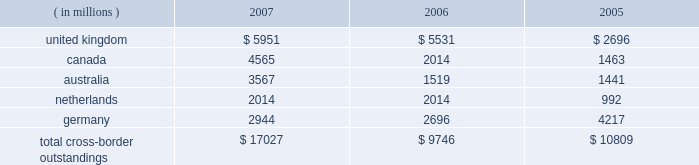Cross-border outstandings to countries in which we do business which amounted to at least 1% ( 1 % ) of our consolidated total assets were as follows as of december 31 : 2007 2006 2005 ( in millions ) .
The total cross-border outstandings presented in the table represented 12% ( 12 % ) , 9% ( 9 % ) and 11% ( 11 % ) of our consolidated total assets as of december 31 , 2007 , 2006 and 2005 , respectively .
There were no cross- border outstandings to countries which totaled between .75% ( .75 % ) and 1% ( 1 % ) of our consolidated total assets as of december 31 , 2007 .
Aggregate cross-border outstandings to countries which totaled between .75% ( .75 % ) and 1% ( 1 % ) of our consolidated total assets at december 31 , 2006 , amounted to $ 1.05 billion ( canada ) and at december 31 , 2005 , amounted to $ 1.86 billion ( belgium and japan ) .
Capital regulatory and economic capital management both use key metrics evaluated by management to ensure that our actual level of capital is commensurate with our risk profile , is in compliance with all regulatory requirements , and is sufficient to provide us with the financial flexibility to undertake future strategic business initiatives .
Regulatory capital our objective with respect to regulatory capital management is to maintain a strong capital base in order to provide financial flexibility for our business needs , including funding corporate growth and supporting customers 2019 cash management needs , and to provide protection against loss to depositors and creditors .
We strive to maintain an optimal level of capital , commensurate with our risk profile , on which an attractive return to shareholders will be realized over both the short and long term , while protecting our obligations to depositors and creditors and satisfying regulatory requirements .
Our capital management process focuses on our risk exposures , our capital position relative to our peers , regulatory capital requirements and the evaluations of the major independent credit rating agencies that assign ratings to our public debt .
The capital committee , working in conjunction with the asset and liability committee , referred to as 2018 2018alco , 2019 2019 oversees the management of regulatory capital , and is responsible for ensuring capital adequacy with respect to regulatory requirements , internal targets and the expectations of the major independent credit rating agencies .
The primary regulator of both state street and state street bank for regulatory capital purposes is the federal reserve board .
Both state street and state street bank are subject to the minimum capital requirements established by the federal reserve board and defined in the federal deposit insurance corporation improvement act of 1991 .
State street bank must meet the regulatory capital thresholds for 2018 2018well capitalized 2019 2019 in order for the parent company to maintain its status as a financial holding company. .
What are the total consolidated assets in 2007? 
Computations: (17027 / 12%)
Answer: 141891.66667. 